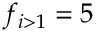Convert formula to latex. <formula><loc_0><loc_0><loc_500><loc_500>f _ { i > 1 } = 5</formula> 